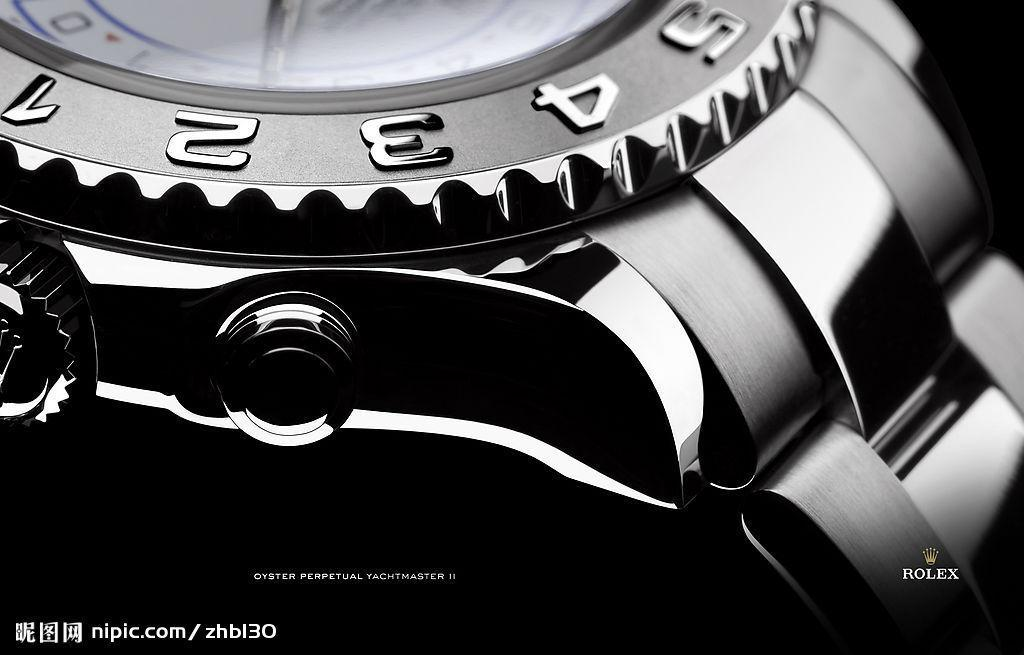Provide a one-sentence caption for the provided image. Close up of a Rolex wtch and part of the band. 